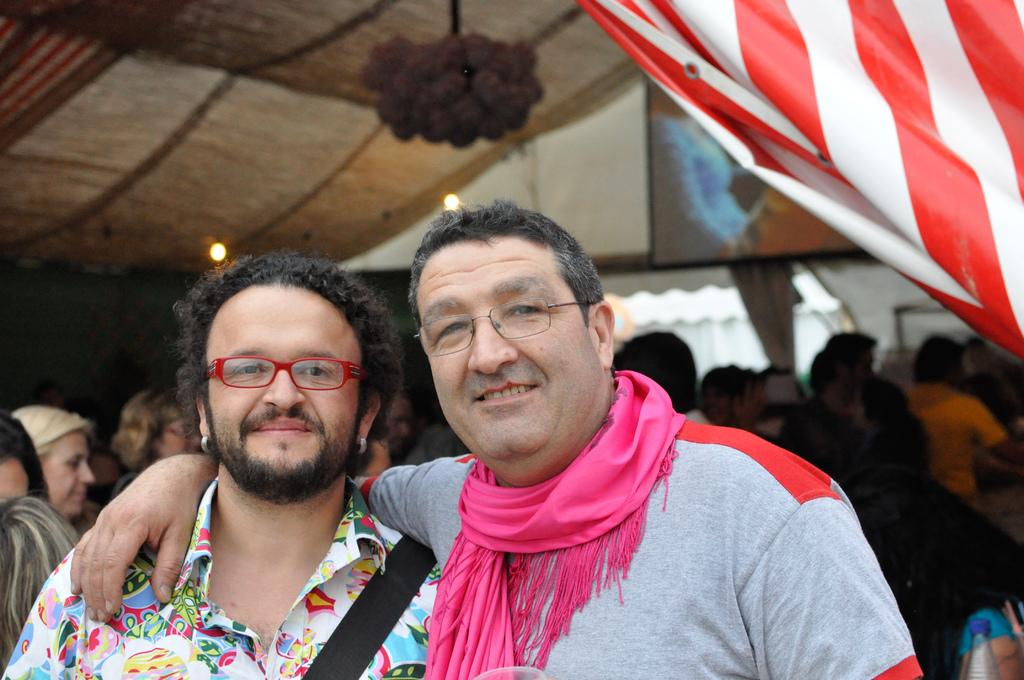What is the main subject of the image? The main subject of the image is a group of people. Can you describe the two men in the foreground? The two men in the foreground are wearing spectacles. What can be seen above the people in the image? There is a roof visible in the image. Can you tell me how many cans are floating in the lake in the image? There is no lake or cans present in the image; it features a group of people and a roof. 